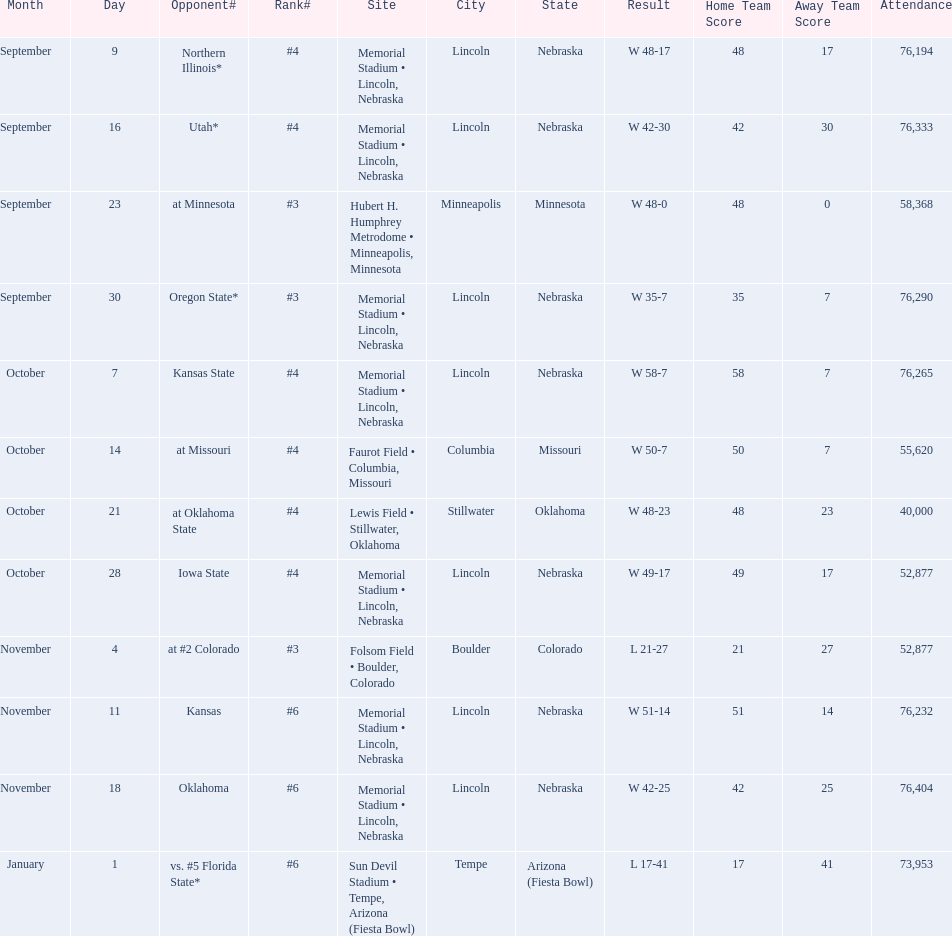Who were all of their opponents? Northern Illinois*, Utah*, at Minnesota, Oregon State*, Kansas State, at Missouri, at Oklahoma State, Iowa State, at #2 Colorado, Kansas, Oklahoma, vs. #5 Florida State*. And what was the attendance of these games? 76,194, 76,333, 58,368, 76,290, 76,265, 55,620, 40,000, 52,877, 52,877, 76,232, 76,404, 73,953. Of those numbers, which is associated with the oregon state game? 76,290. 